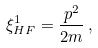Convert formula to latex. <formula><loc_0><loc_0><loc_500><loc_500>\xi _ { H F } ^ { 1 } = \frac { { p } ^ { 2 } } { 2 m } \, ,</formula> 